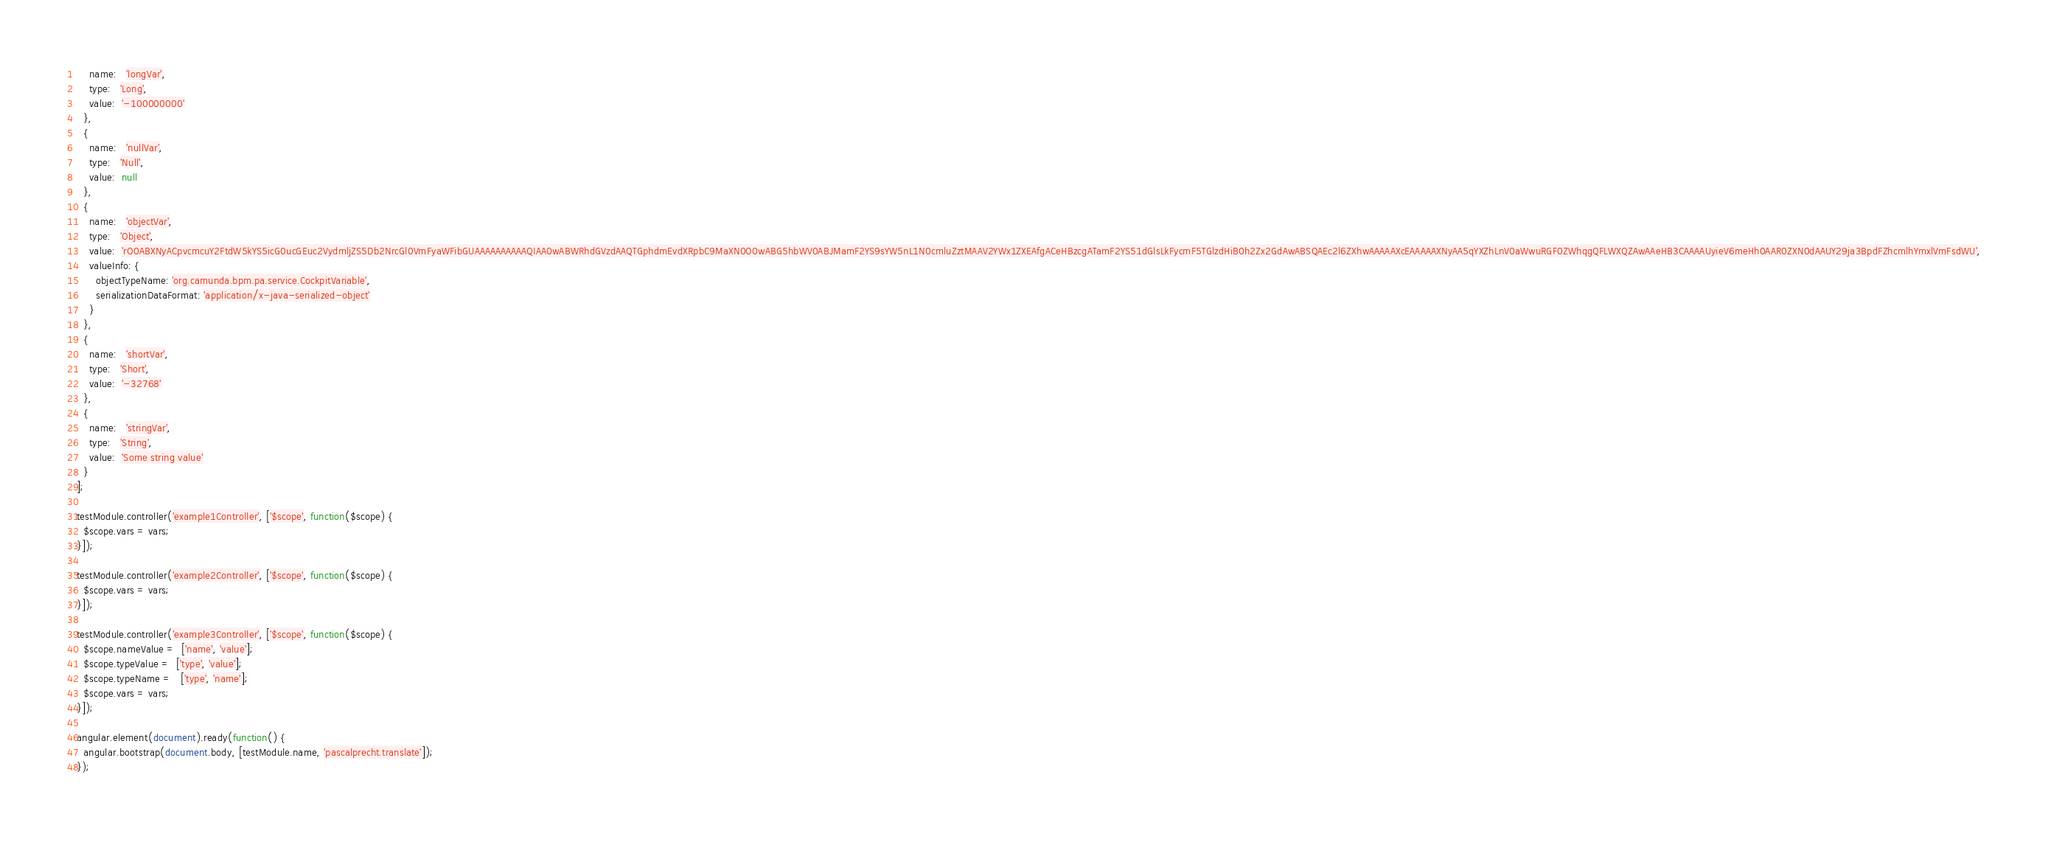<code> <loc_0><loc_0><loc_500><loc_500><_JavaScript_>    name:   'longVar',
    type:   'Long',
    value:  '-100000000'
  },
  {
    name:   'nullVar',
    type:   'Null',
    value:  null
  },
  {
    name:   'objectVar',
    type:   'Object',
    value:  'rO0ABXNyACpvcmcuY2FtdW5kYS5icG0ucGEuc2VydmljZS5Db2NrcGl0VmFyaWFibGUAAAAAAAAAAQIAA0wABWRhdGVzdAAQTGphdmEvdXRpbC9MaXN0O0wABG5hbWV0ABJMamF2YS9sYW5nL1N0cmluZztMAAV2YWx1ZXEAfgACeHBzcgATamF2YS51dGlsLkFycmF5TGlzdHiB0h2Zx2GdAwABSQAEc2l6ZXhwAAAAAXcEAAAAAXNyAA5qYXZhLnV0aWwuRGF0ZWhqgQFLWXQZAwAAeHB3CAAAAUyieV6meHh0AAR0ZXN0dAAUY29ja3BpdFZhcmlhYmxlVmFsdWU',
    valueInfo: {
      objectTypeName: 'org.camunda.bpm.pa.service.CockpitVariable',
      serializationDataFormat: 'application/x-java-serialized-object'
    }
  },
  {
    name:   'shortVar',
    type:   'Short',
    value:  '-32768'
  },
  {
    name:   'stringVar',
    type:   'String',
    value:  'Some string value'
  }
];

testModule.controller('example1Controller', ['$scope', function($scope) {
  $scope.vars = vars;
}]);

testModule.controller('example2Controller', ['$scope', function($scope) {
  $scope.vars = vars;
}]);

testModule.controller('example3Controller', ['$scope', function($scope) {
  $scope.nameValue =  ['name', 'value'];
  $scope.typeValue =  ['type', 'value'];
  $scope.typeName =   ['type', 'name'];
  $scope.vars = vars;
}]);

angular.element(document).ready(function() {
  angular.bootstrap(document.body, [testModule.name, 'pascalprecht.translate']);
});
</code> 